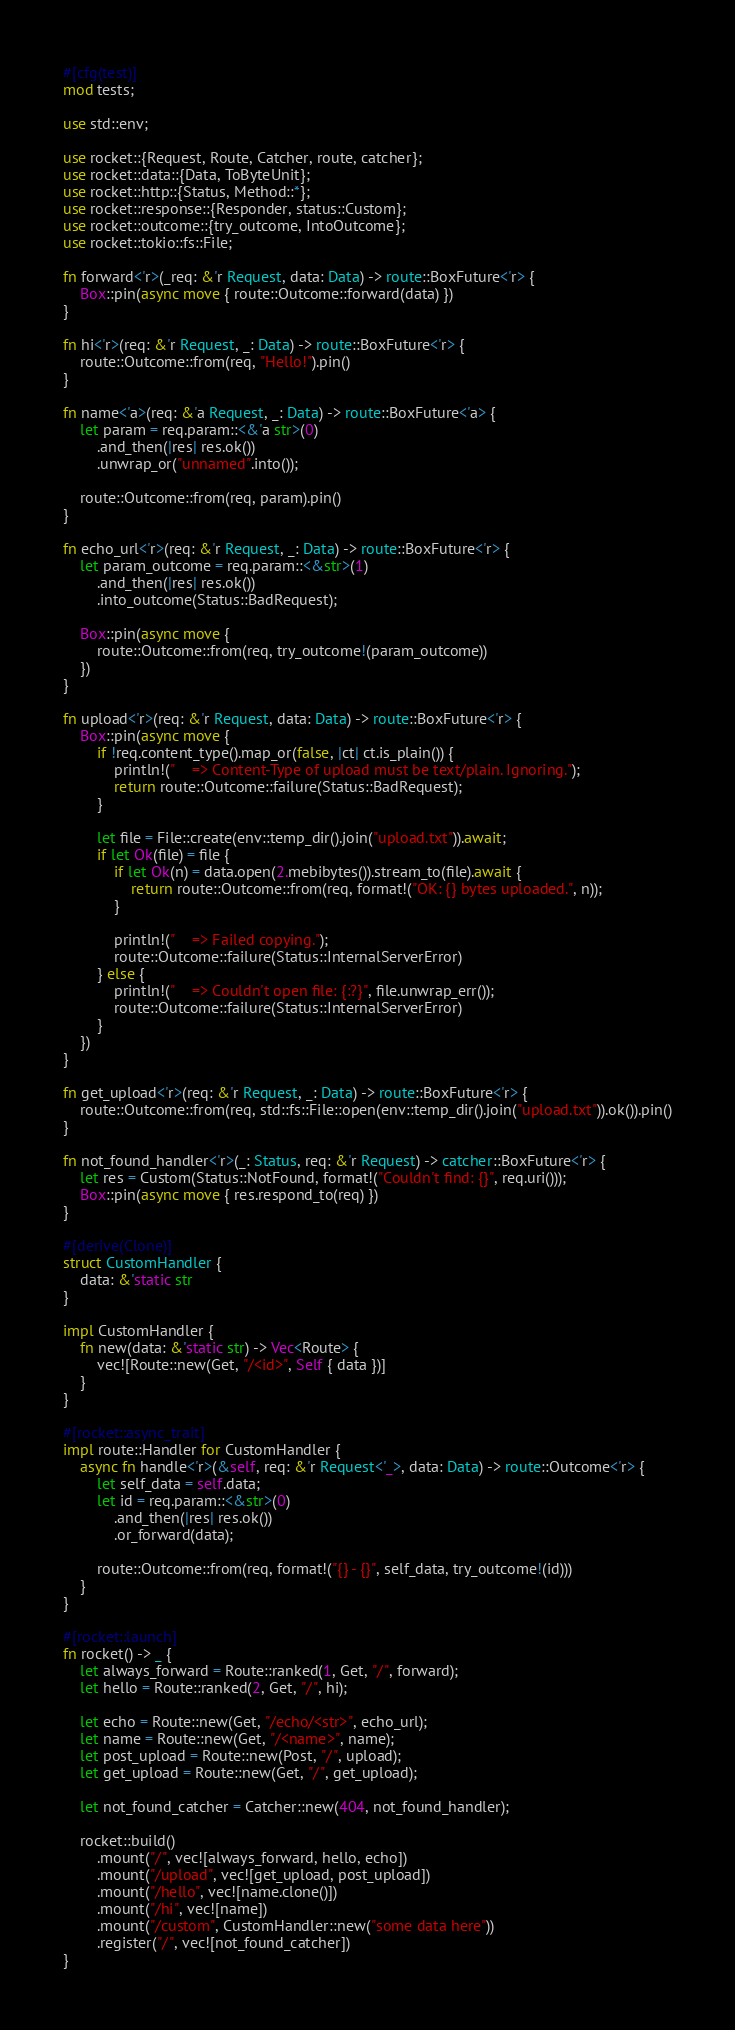<code> <loc_0><loc_0><loc_500><loc_500><_Rust_>#[cfg(test)]
mod tests;

use std::env;

use rocket::{Request, Route, Catcher, route, catcher};
use rocket::data::{Data, ToByteUnit};
use rocket::http::{Status, Method::*};
use rocket::response::{Responder, status::Custom};
use rocket::outcome::{try_outcome, IntoOutcome};
use rocket::tokio::fs::File;

fn forward<'r>(_req: &'r Request, data: Data) -> route::BoxFuture<'r> {
    Box::pin(async move { route::Outcome::forward(data) })
}

fn hi<'r>(req: &'r Request, _: Data) -> route::BoxFuture<'r> {
    route::Outcome::from(req, "Hello!").pin()
}

fn name<'a>(req: &'a Request, _: Data) -> route::BoxFuture<'a> {
    let param = req.param::<&'a str>(0)
        .and_then(|res| res.ok())
        .unwrap_or("unnamed".into());

    route::Outcome::from(req, param).pin()
}

fn echo_url<'r>(req: &'r Request, _: Data) -> route::BoxFuture<'r> {
    let param_outcome = req.param::<&str>(1)
        .and_then(|res| res.ok())
        .into_outcome(Status::BadRequest);

    Box::pin(async move {
        route::Outcome::from(req, try_outcome!(param_outcome))
    })
}

fn upload<'r>(req: &'r Request, data: Data) -> route::BoxFuture<'r> {
    Box::pin(async move {
        if !req.content_type().map_or(false, |ct| ct.is_plain()) {
            println!("    => Content-Type of upload must be text/plain. Ignoring.");
            return route::Outcome::failure(Status::BadRequest);
        }

        let file = File::create(env::temp_dir().join("upload.txt")).await;
        if let Ok(file) = file {
            if let Ok(n) = data.open(2.mebibytes()).stream_to(file).await {
                return route::Outcome::from(req, format!("OK: {} bytes uploaded.", n));
            }

            println!("    => Failed copying.");
            route::Outcome::failure(Status::InternalServerError)
        } else {
            println!("    => Couldn't open file: {:?}", file.unwrap_err());
            route::Outcome::failure(Status::InternalServerError)
        }
    })
}

fn get_upload<'r>(req: &'r Request, _: Data) -> route::BoxFuture<'r> {
    route::Outcome::from(req, std::fs::File::open(env::temp_dir().join("upload.txt")).ok()).pin()
}

fn not_found_handler<'r>(_: Status, req: &'r Request) -> catcher::BoxFuture<'r> {
    let res = Custom(Status::NotFound, format!("Couldn't find: {}", req.uri()));
    Box::pin(async move { res.respond_to(req) })
}

#[derive(Clone)]
struct CustomHandler {
    data: &'static str
}

impl CustomHandler {
    fn new(data: &'static str) -> Vec<Route> {
        vec![Route::new(Get, "/<id>", Self { data })]
    }
}

#[rocket::async_trait]
impl route::Handler for CustomHandler {
    async fn handle<'r>(&self, req: &'r Request<'_>, data: Data) -> route::Outcome<'r> {
        let self_data = self.data;
        let id = req.param::<&str>(0)
            .and_then(|res| res.ok())
            .or_forward(data);

        route::Outcome::from(req, format!("{} - {}", self_data, try_outcome!(id)))
    }
}

#[rocket::launch]
fn rocket() -> _ {
    let always_forward = Route::ranked(1, Get, "/", forward);
    let hello = Route::ranked(2, Get, "/", hi);

    let echo = Route::new(Get, "/echo/<str>", echo_url);
    let name = Route::new(Get, "/<name>", name);
    let post_upload = Route::new(Post, "/", upload);
    let get_upload = Route::new(Get, "/", get_upload);

    let not_found_catcher = Catcher::new(404, not_found_handler);

    rocket::build()
        .mount("/", vec![always_forward, hello, echo])
        .mount("/upload", vec![get_upload, post_upload])
        .mount("/hello", vec![name.clone()])
        .mount("/hi", vec![name])
        .mount("/custom", CustomHandler::new("some data here"))
        .register("/", vec![not_found_catcher])
}
</code> 